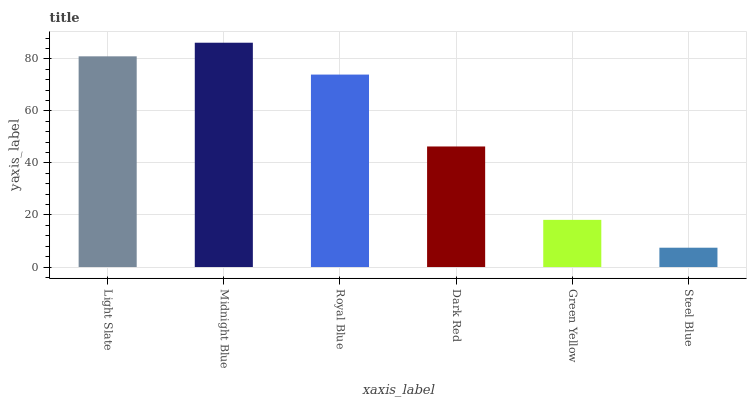Is Steel Blue the minimum?
Answer yes or no. Yes. Is Midnight Blue the maximum?
Answer yes or no. Yes. Is Royal Blue the minimum?
Answer yes or no. No. Is Royal Blue the maximum?
Answer yes or no. No. Is Midnight Blue greater than Royal Blue?
Answer yes or no. Yes. Is Royal Blue less than Midnight Blue?
Answer yes or no. Yes. Is Royal Blue greater than Midnight Blue?
Answer yes or no. No. Is Midnight Blue less than Royal Blue?
Answer yes or no. No. Is Royal Blue the high median?
Answer yes or no. Yes. Is Dark Red the low median?
Answer yes or no. Yes. Is Midnight Blue the high median?
Answer yes or no. No. Is Steel Blue the low median?
Answer yes or no. No. 